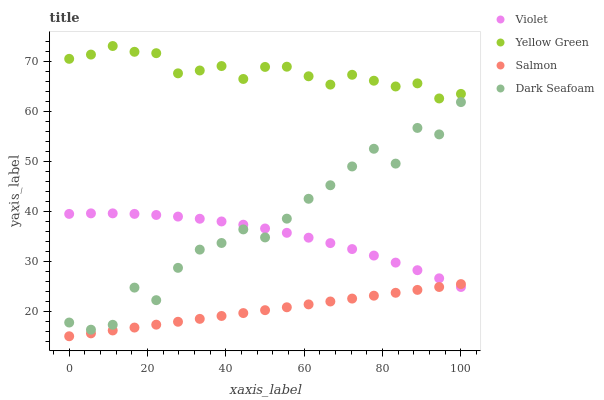Does Salmon have the minimum area under the curve?
Answer yes or no. Yes. Does Yellow Green have the maximum area under the curve?
Answer yes or no. Yes. Does Yellow Green have the minimum area under the curve?
Answer yes or no. No. Does Salmon have the maximum area under the curve?
Answer yes or no. No. Is Salmon the smoothest?
Answer yes or no. Yes. Is Dark Seafoam the roughest?
Answer yes or no. Yes. Is Yellow Green the smoothest?
Answer yes or no. No. Is Yellow Green the roughest?
Answer yes or no. No. Does Salmon have the lowest value?
Answer yes or no. Yes. Does Yellow Green have the lowest value?
Answer yes or no. No. Does Yellow Green have the highest value?
Answer yes or no. Yes. Does Salmon have the highest value?
Answer yes or no. No. Is Violet less than Yellow Green?
Answer yes or no. Yes. Is Yellow Green greater than Violet?
Answer yes or no. Yes. Does Dark Seafoam intersect Violet?
Answer yes or no. Yes. Is Dark Seafoam less than Violet?
Answer yes or no. No. Is Dark Seafoam greater than Violet?
Answer yes or no. No. Does Violet intersect Yellow Green?
Answer yes or no. No. 